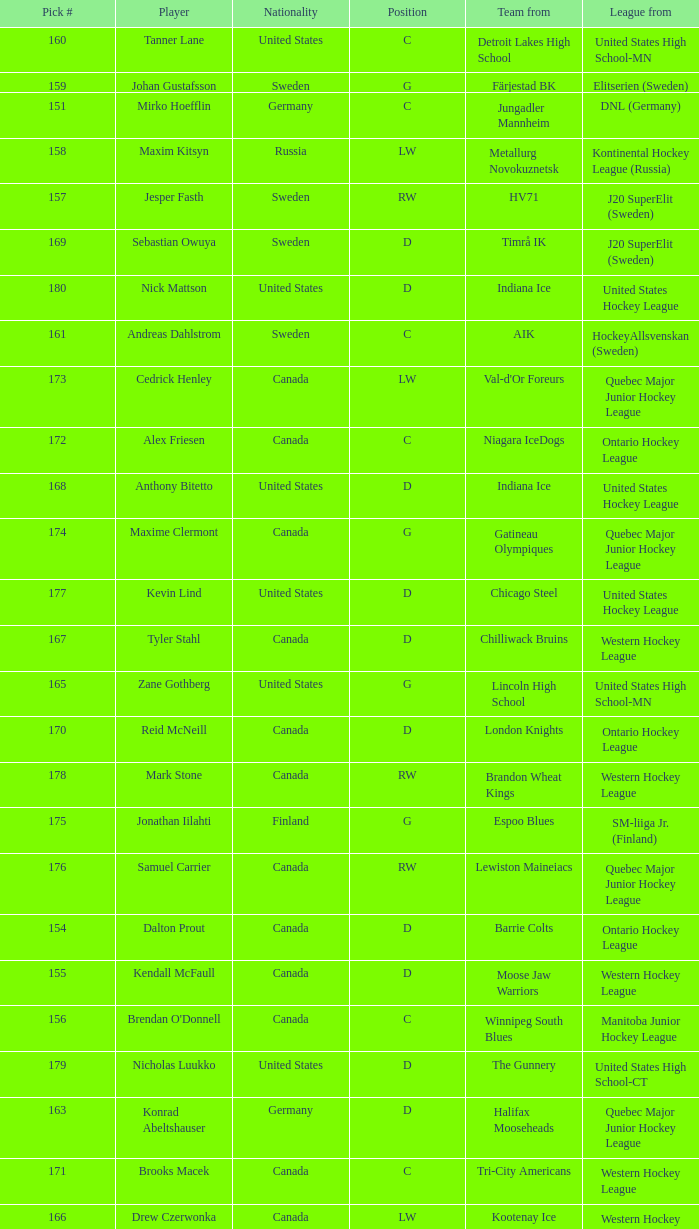What is the league that has the pick #160? United States High School-MN. 